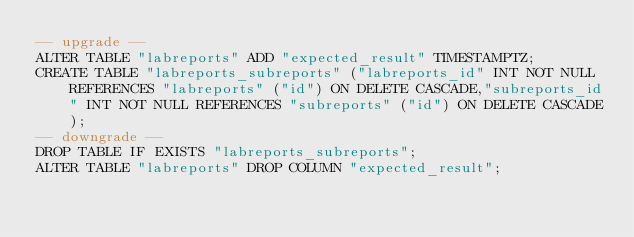<code> <loc_0><loc_0><loc_500><loc_500><_SQL_>-- upgrade --
ALTER TABLE "labreports" ADD "expected_result" TIMESTAMPTZ;
CREATE TABLE "labreports_subreports" ("labreports_id" INT NOT NULL REFERENCES "labreports" ("id") ON DELETE CASCADE,"subreports_id" INT NOT NULL REFERENCES "subreports" ("id") ON DELETE CASCADE);
-- downgrade --
DROP TABLE IF EXISTS "labreports_subreports";
ALTER TABLE "labreports" DROP COLUMN "expected_result";
</code> 